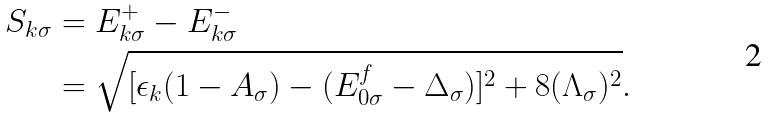Convert formula to latex. <formula><loc_0><loc_0><loc_500><loc_500>S _ { { k } \sigma } & = E ^ { + } _ { { k } \sigma } - E ^ { - } _ { { k } \sigma } \\ & = \sqrt { [ \epsilon _ { k } ( 1 - A _ { \sigma } ) - ( E _ { 0 \sigma } ^ { f } - \Delta _ { \sigma } ) ] ^ { 2 } + 8 ( \Lambda _ { \sigma } ) ^ { 2 } } .</formula> 